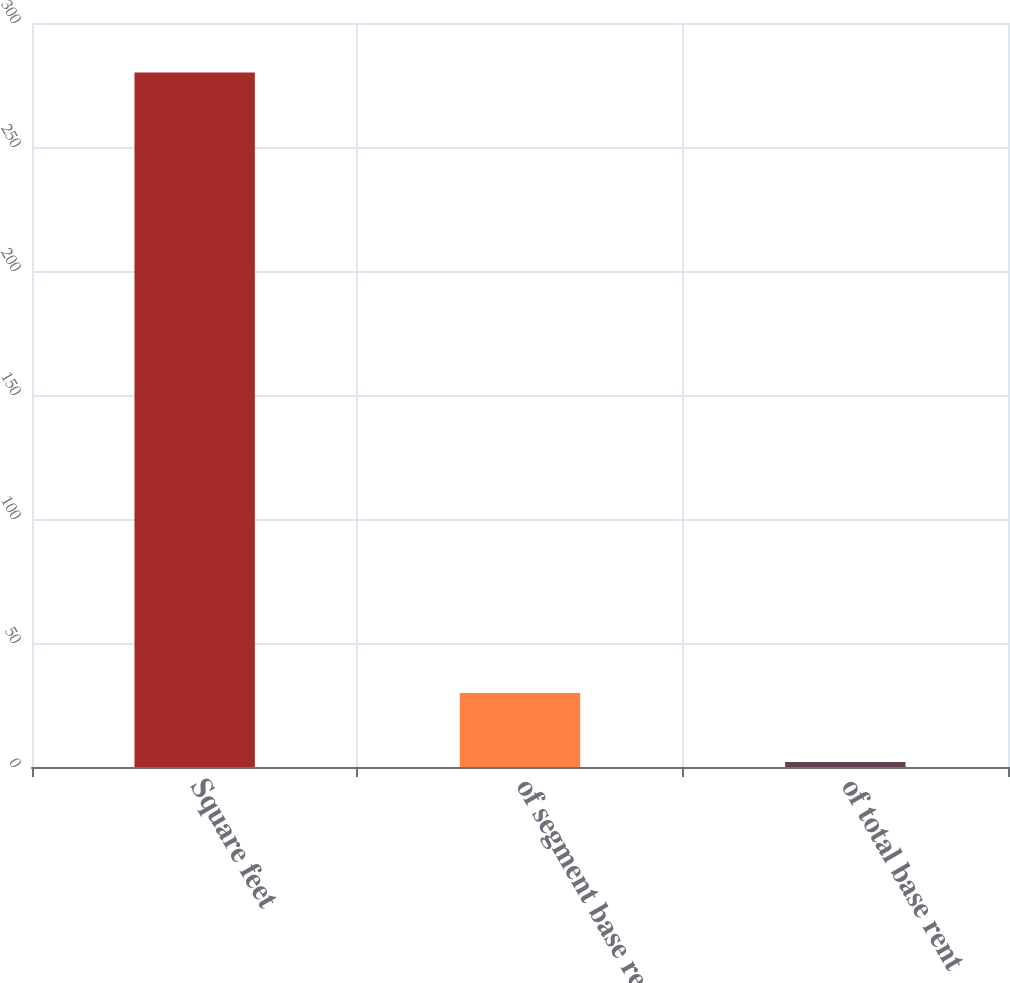<chart> <loc_0><loc_0><loc_500><loc_500><bar_chart><fcel>Square feet<fcel>of segment base rent<fcel>of total base rent<nl><fcel>280<fcel>29.8<fcel>2<nl></chart> 